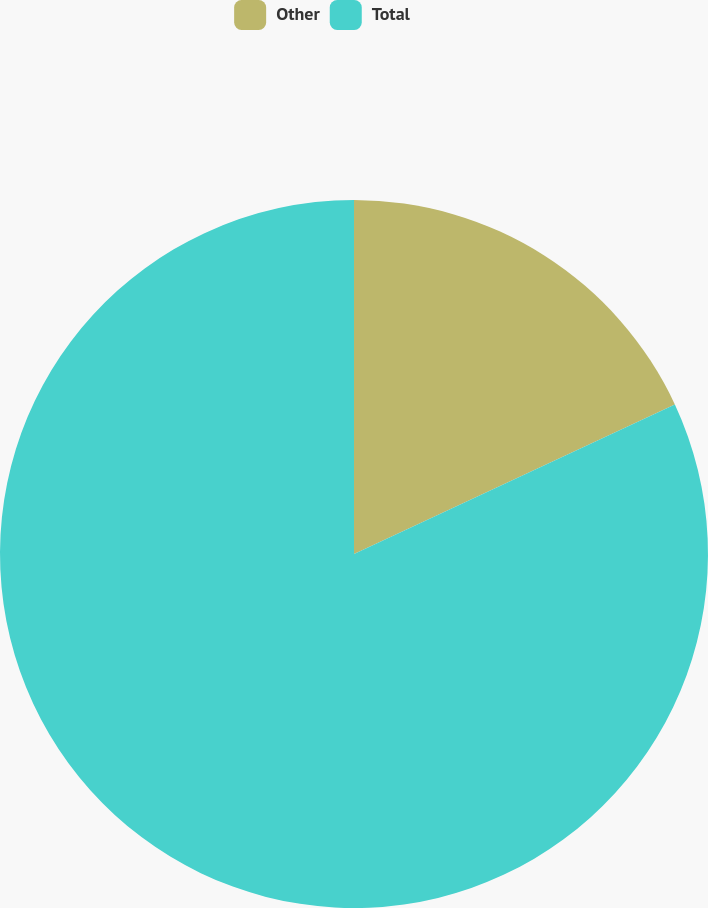Convert chart. <chart><loc_0><loc_0><loc_500><loc_500><pie_chart><fcel>Other<fcel>Total<nl><fcel>18.06%<fcel>81.94%<nl></chart> 